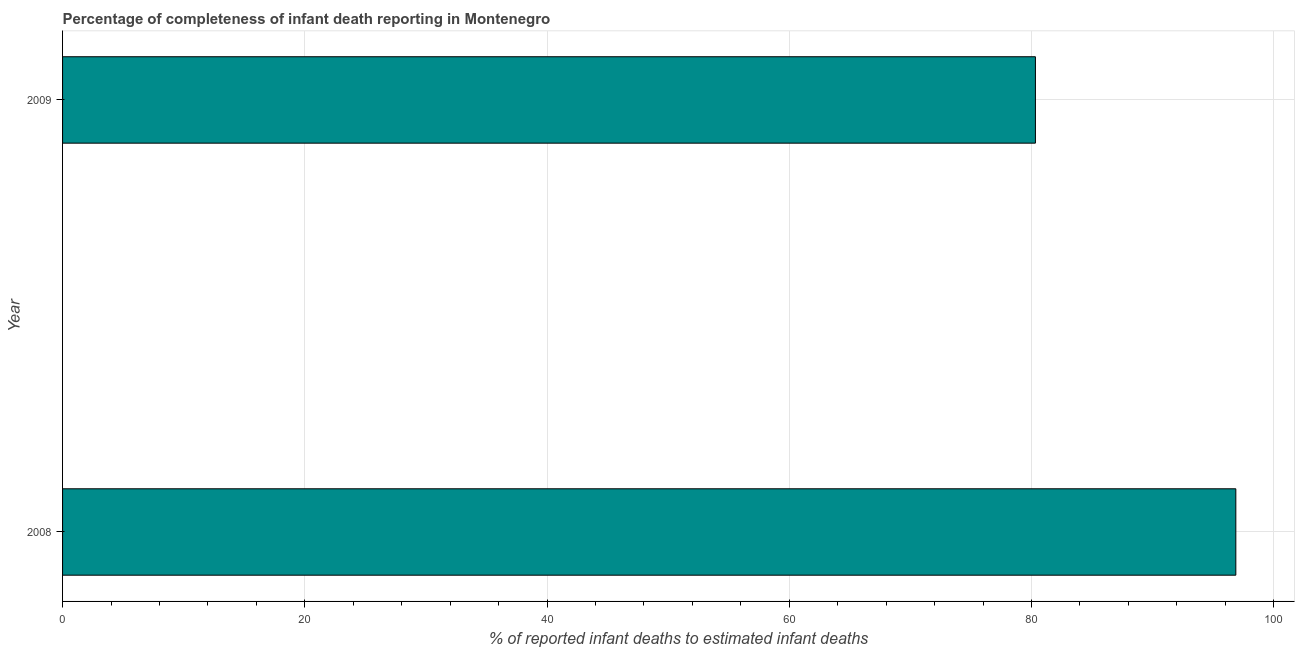Does the graph contain any zero values?
Make the answer very short. No. What is the title of the graph?
Provide a succinct answer. Percentage of completeness of infant death reporting in Montenegro. What is the label or title of the X-axis?
Your response must be concise. % of reported infant deaths to estimated infant deaths. What is the label or title of the Y-axis?
Your answer should be compact. Year. What is the completeness of infant death reporting in 2009?
Your answer should be very brief. 80.33. Across all years, what is the maximum completeness of infant death reporting?
Provide a succinct answer. 96.88. Across all years, what is the minimum completeness of infant death reporting?
Provide a succinct answer. 80.33. In which year was the completeness of infant death reporting minimum?
Offer a terse response. 2009. What is the sum of the completeness of infant death reporting?
Offer a terse response. 177.2. What is the difference between the completeness of infant death reporting in 2008 and 2009?
Provide a succinct answer. 16.55. What is the average completeness of infant death reporting per year?
Your answer should be very brief. 88.6. What is the median completeness of infant death reporting?
Keep it short and to the point. 88.6. Do a majority of the years between 2008 and 2009 (inclusive) have completeness of infant death reporting greater than 20 %?
Offer a very short reply. Yes. What is the ratio of the completeness of infant death reporting in 2008 to that in 2009?
Ensure brevity in your answer.  1.21. How many bars are there?
Your answer should be very brief. 2. What is the difference between two consecutive major ticks on the X-axis?
Give a very brief answer. 20. Are the values on the major ticks of X-axis written in scientific E-notation?
Offer a terse response. No. What is the % of reported infant deaths to estimated infant deaths in 2008?
Give a very brief answer. 96.88. What is the % of reported infant deaths to estimated infant deaths of 2009?
Give a very brief answer. 80.33. What is the difference between the % of reported infant deaths to estimated infant deaths in 2008 and 2009?
Offer a terse response. 16.55. What is the ratio of the % of reported infant deaths to estimated infant deaths in 2008 to that in 2009?
Give a very brief answer. 1.21. 